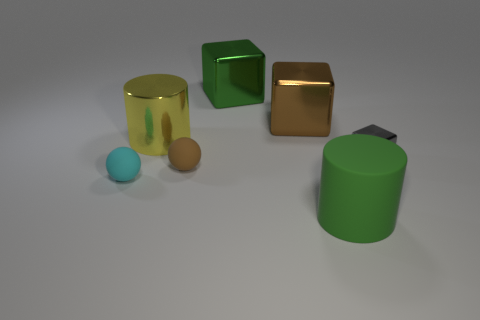Add 3 tiny yellow cubes. How many objects exist? 10 Subtract all balls. How many objects are left? 5 Subtract all big green metal objects. Subtract all yellow things. How many objects are left? 5 Add 3 big green cubes. How many big green cubes are left? 4 Add 7 small metallic things. How many small metallic things exist? 8 Subtract 0 yellow spheres. How many objects are left? 7 